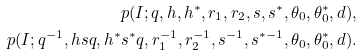Convert formula to latex. <formula><loc_0><loc_0><loc_500><loc_500>p ( I ; q , h , h ^ { * } , r _ { 1 } , r _ { 2 } , s , s ^ { * } , \theta _ { 0 } , \theta _ { 0 } ^ { * } , d ) , \\ p ( I ; q ^ { - 1 } , h s q , h ^ { * } s ^ { * } q , r _ { 1 } ^ { - 1 } , r _ { 2 } ^ { - 1 } , s ^ { - 1 } , s ^ { * - 1 } , \theta _ { 0 } , \theta _ { 0 } ^ { * } , d ) .</formula> 